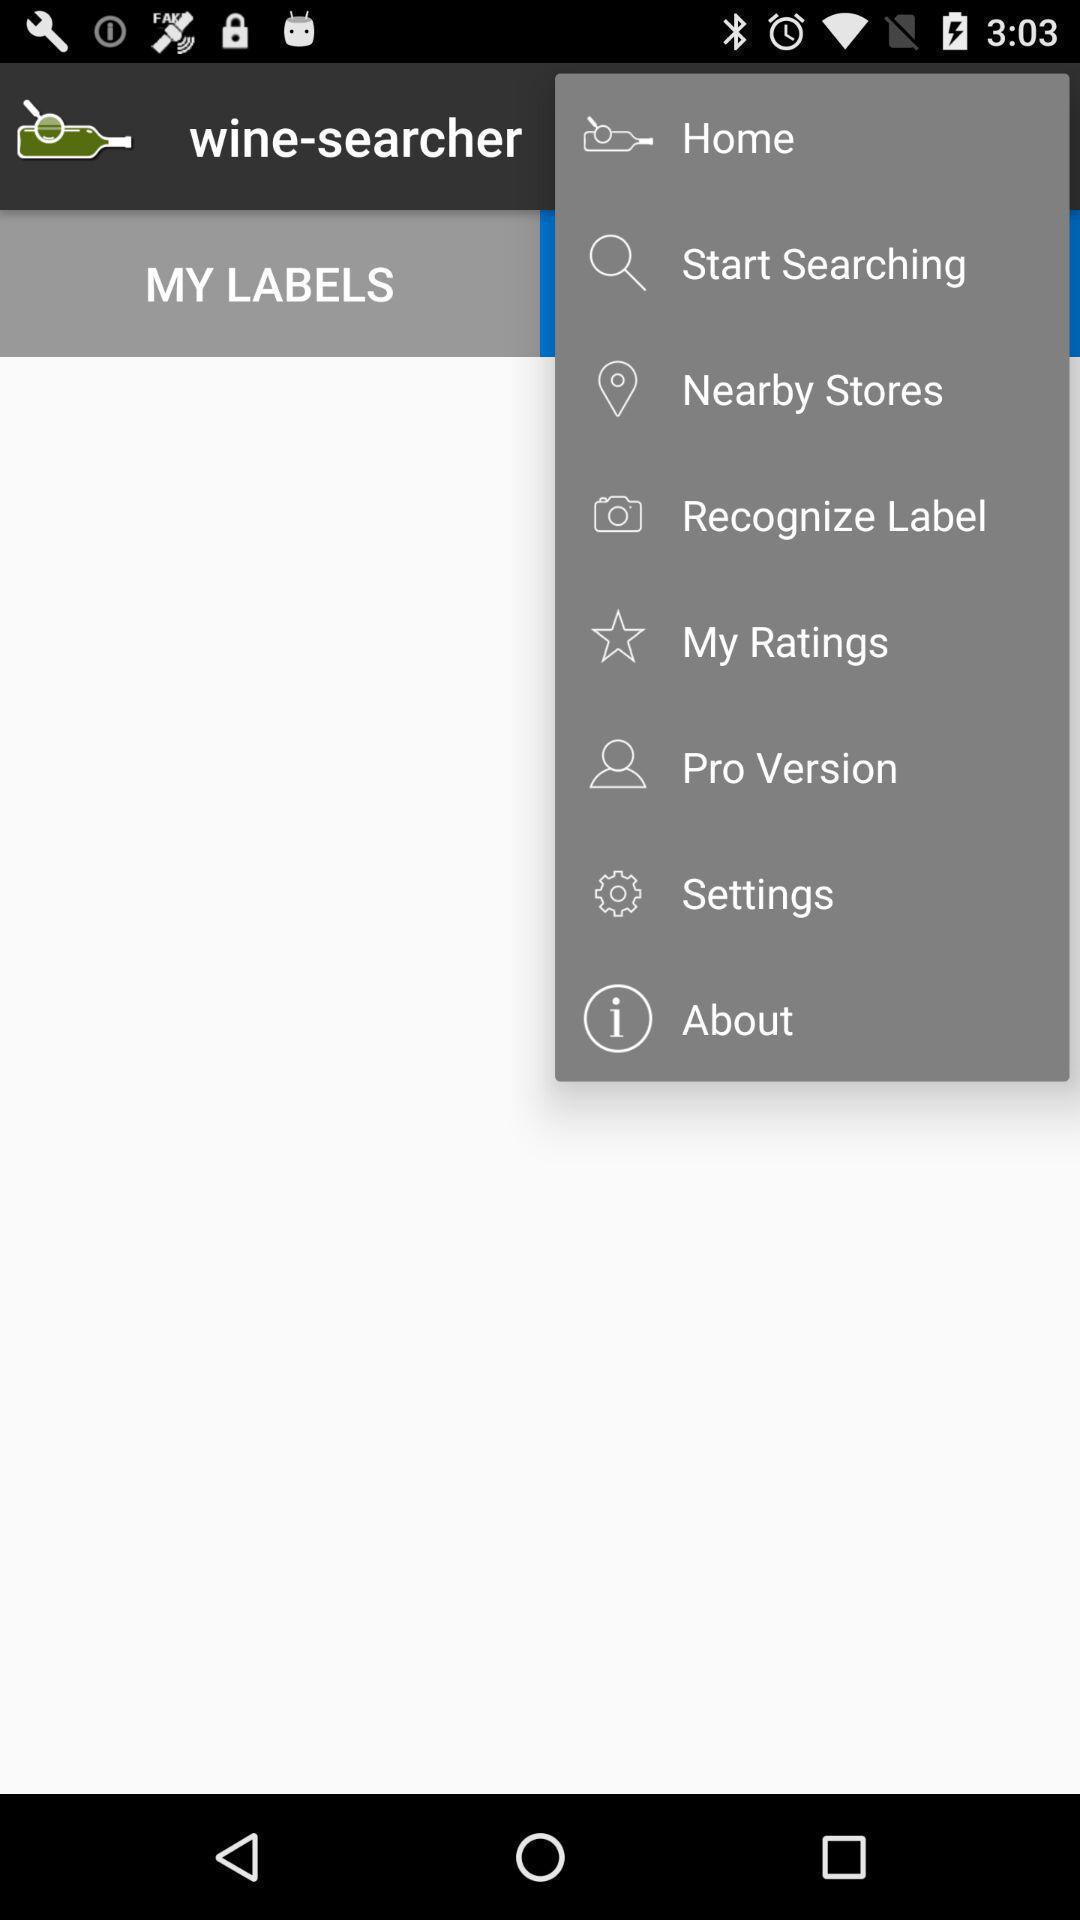Give me a summary of this screen capture. Pop up list of different options of the app. 